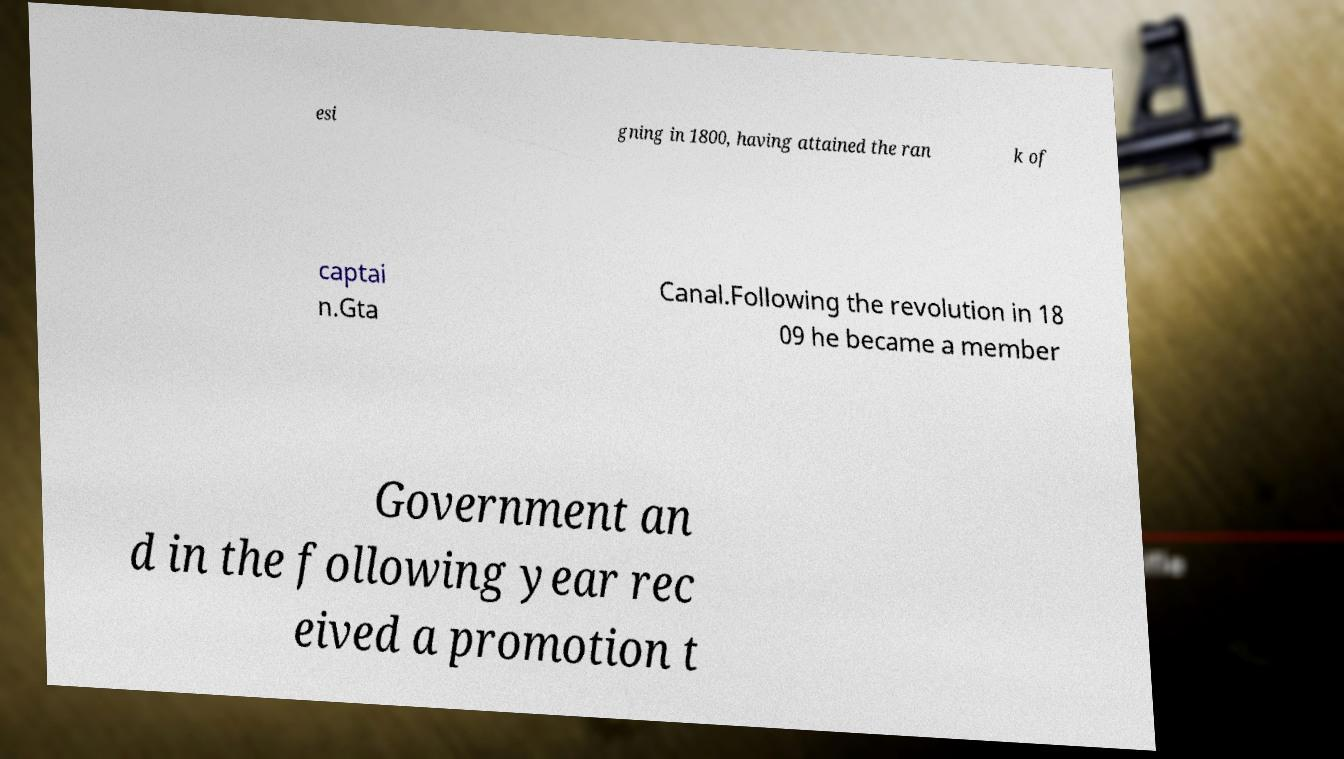Can you accurately transcribe the text from the provided image for me? esi gning in 1800, having attained the ran k of captai n.Gta Canal.Following the revolution in 18 09 he became a member Government an d in the following year rec eived a promotion t 